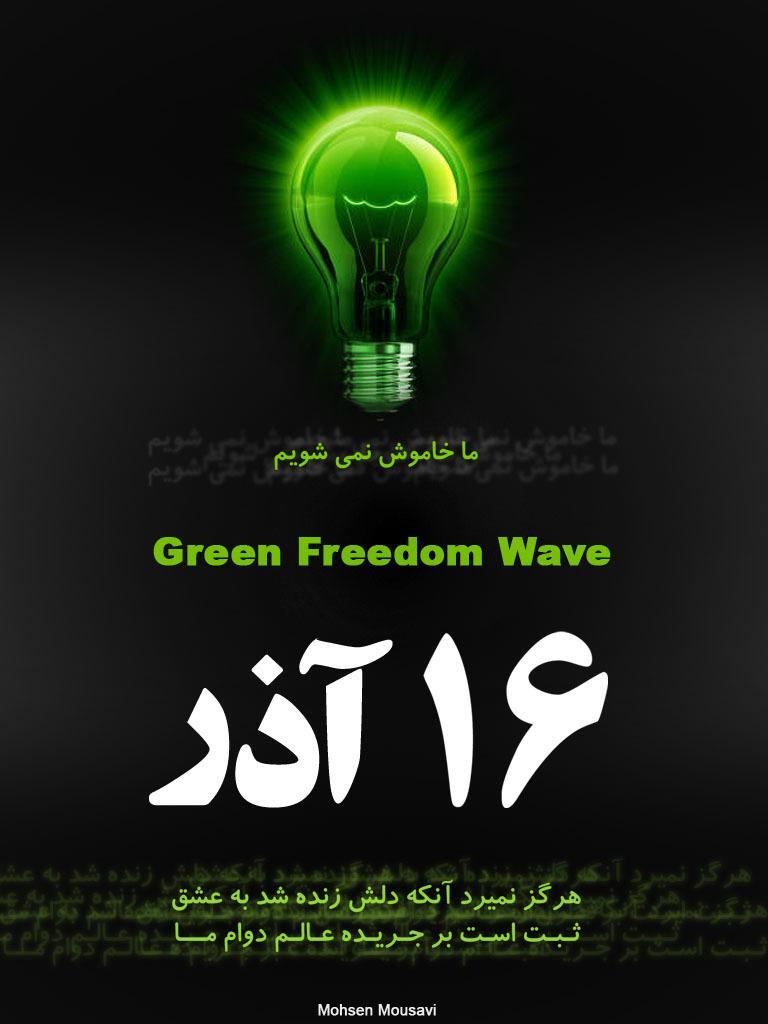Could you give a brief overview of what you see in this image? In this picture, we see a green color bulb. In the middle of the picture, we see some text written in English language. At the bottom, we see some text written in Urdu language. In the background, it is black in color. This picture might be a poster. 